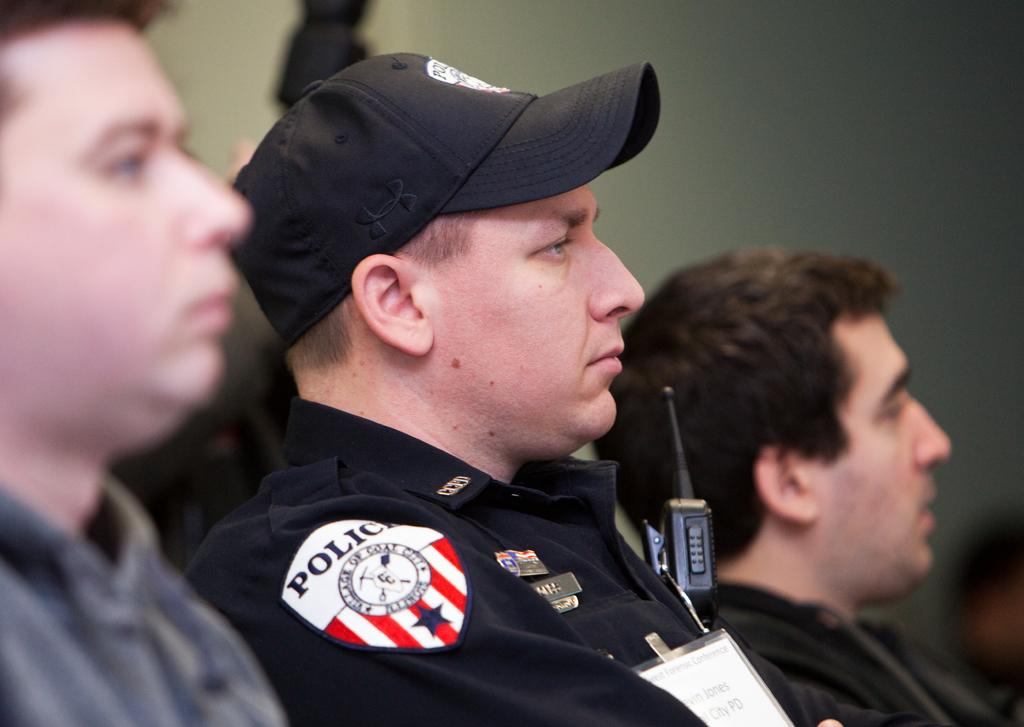Who or what is present in the image? There are people in the image. Can you describe the clothing of the people in the image? The people are wearing different color dresses. What can be observed about the background of the image? The background of the image is blurred. What type of discovery was made at the edge of the image? There is no mention of a discovery or an edge in the image, so it cannot be determined from the image. 